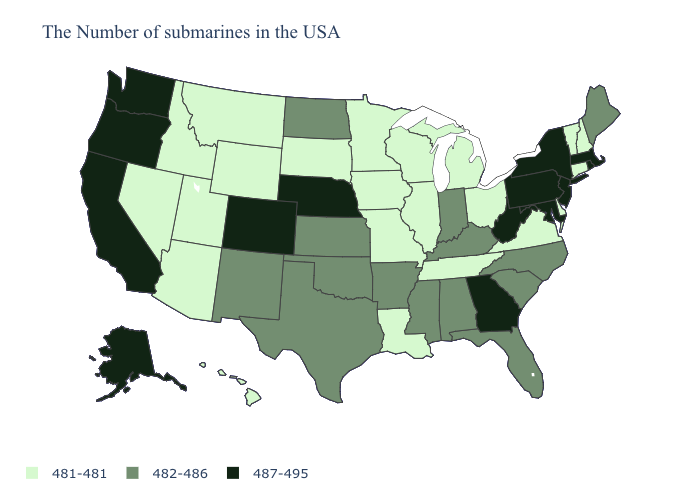Among the states that border Tennessee , which have the lowest value?
Answer briefly. Virginia, Missouri. What is the highest value in the USA?
Concise answer only. 487-495. Does Florida have the lowest value in the USA?
Keep it brief. No. What is the value of Nebraska?
Quick response, please. 487-495. Among the states that border North Dakota , which have the lowest value?
Give a very brief answer. Minnesota, South Dakota, Montana. What is the highest value in the USA?
Short answer required. 487-495. Which states have the highest value in the USA?
Give a very brief answer. Massachusetts, Rhode Island, New York, New Jersey, Maryland, Pennsylvania, West Virginia, Georgia, Nebraska, Colorado, California, Washington, Oregon, Alaska. What is the value of New Jersey?
Quick response, please. 487-495. Does Connecticut have the highest value in the Northeast?
Keep it brief. No. Which states have the lowest value in the USA?
Quick response, please. New Hampshire, Vermont, Connecticut, Delaware, Virginia, Ohio, Michigan, Tennessee, Wisconsin, Illinois, Louisiana, Missouri, Minnesota, Iowa, South Dakota, Wyoming, Utah, Montana, Arizona, Idaho, Nevada, Hawaii. What is the value of Nebraska?
Give a very brief answer. 487-495. Which states have the lowest value in the USA?
Answer briefly. New Hampshire, Vermont, Connecticut, Delaware, Virginia, Ohio, Michigan, Tennessee, Wisconsin, Illinois, Louisiana, Missouri, Minnesota, Iowa, South Dakota, Wyoming, Utah, Montana, Arizona, Idaho, Nevada, Hawaii. What is the lowest value in the MidWest?
Be succinct. 481-481. What is the value of Arizona?
Give a very brief answer. 481-481. 